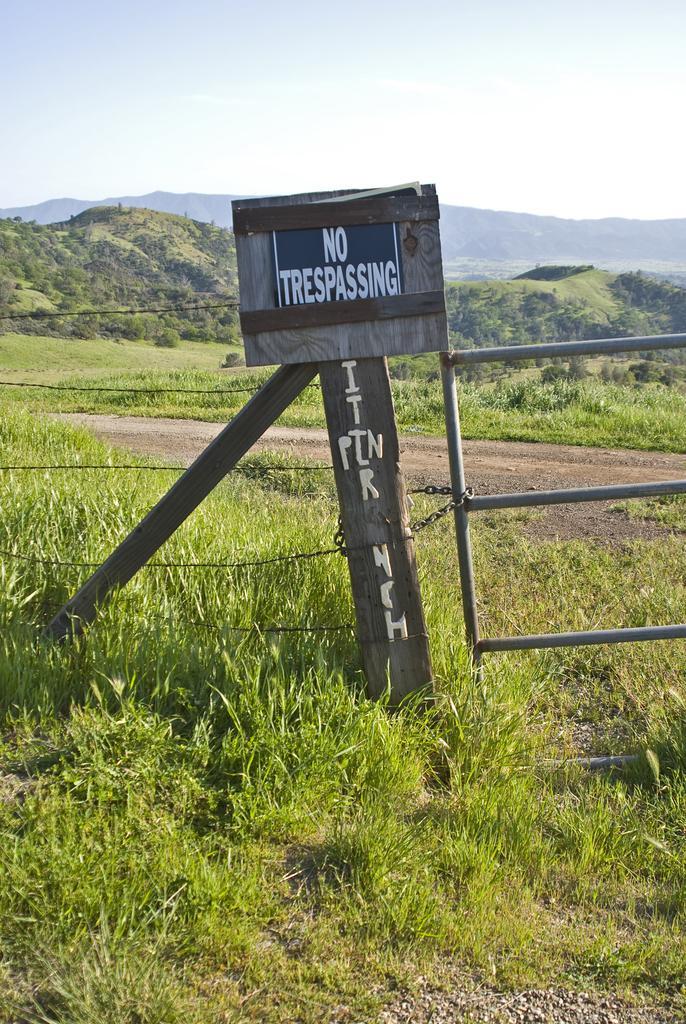Describe this image in one or two sentences. In this image in the front there is grass on the ground and in the center there is a railing and there is a board with some text written on it. In the background there are trees, mountains and the sky is cloudy. 